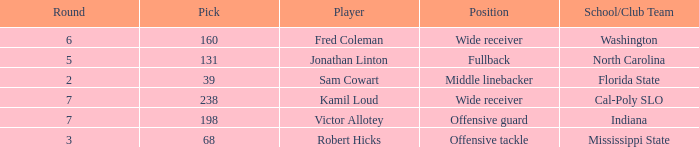Which School/Club Team has a Pick of 198? Indiana. 